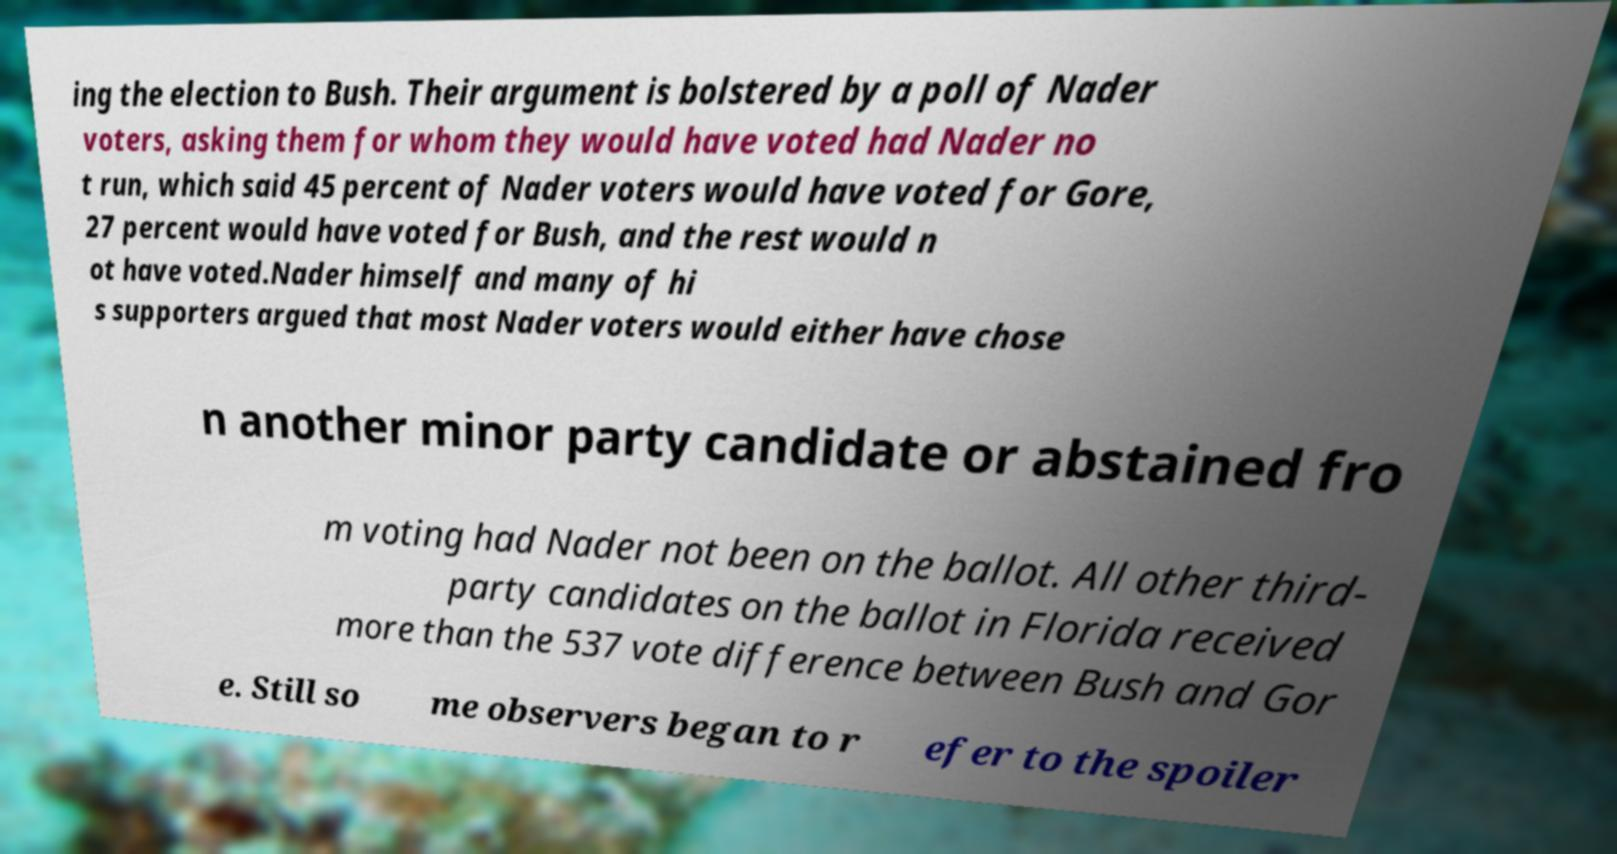Can you read and provide the text displayed in the image?This photo seems to have some interesting text. Can you extract and type it out for me? ing the election to Bush. Their argument is bolstered by a poll of Nader voters, asking them for whom they would have voted had Nader no t run, which said 45 percent of Nader voters would have voted for Gore, 27 percent would have voted for Bush, and the rest would n ot have voted.Nader himself and many of hi s supporters argued that most Nader voters would either have chose n another minor party candidate or abstained fro m voting had Nader not been on the ballot. All other third- party candidates on the ballot in Florida received more than the 537 vote difference between Bush and Gor e. Still so me observers began to r efer to the spoiler 